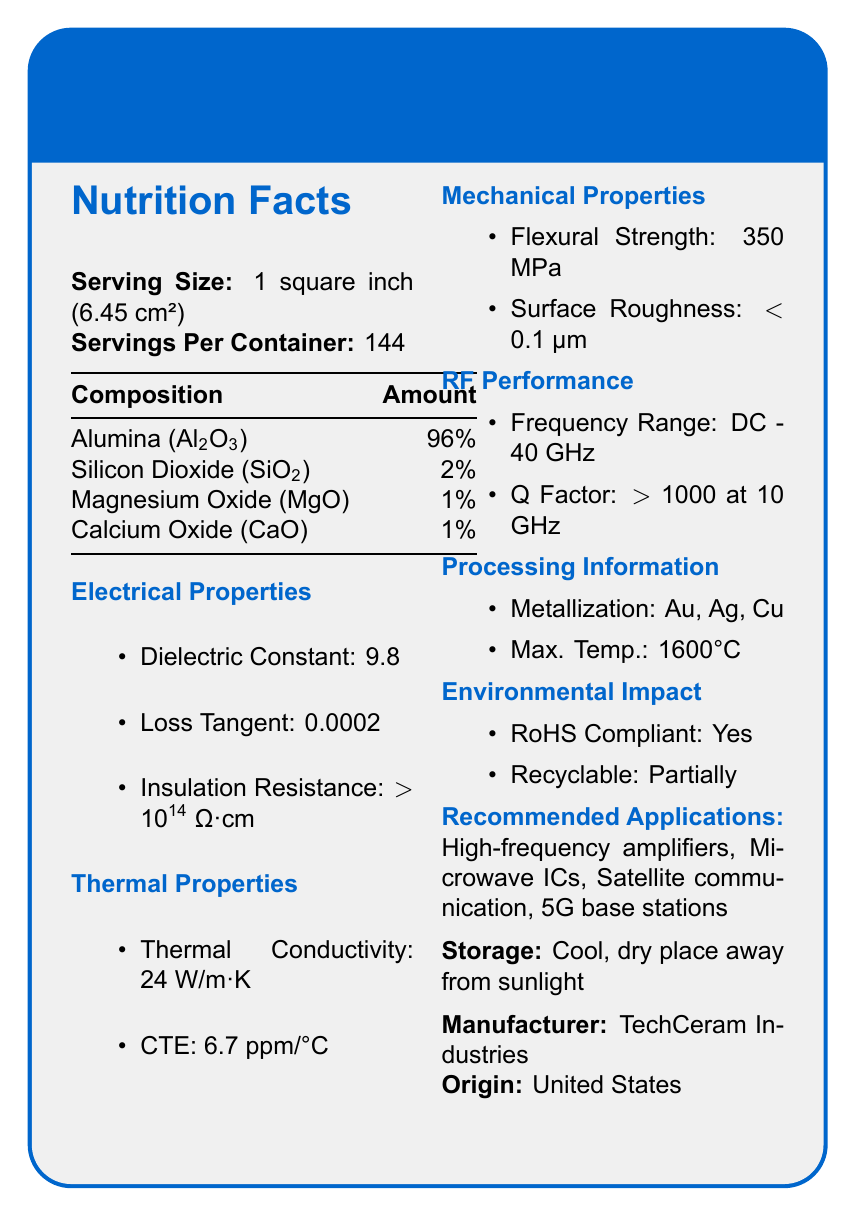what is the product name? The product name is clearly mentioned at the top of the document and in the title, "RF-Grade Ceramic Substrate".
Answer: RF-Grade Ceramic Substrate what is the insulation resistance of the ceramic substrate? Under the Electrical Properties section, the insulation resistance is listed as "> 10^14 Ω·cm".
Answer: > 10^14 Ω·cm What is the dielectric constant of this ceramic substrate? The dielectric constant is explicitly mentioned under the Electrical Properties section with a value of 9.8.
Answer: 9.8 which metals are compatible with metallization processes for this substrate? The Processing Information section lists "Gold, Silver, Copper" as compatible with metallization processes.
Answer: Gold, Silver, Copper What frequency range does the ceramic substrate support? The RF Performance section indicates that the ceramic substrate supports a frequency range from DC to 40 GHz.
Answer: DC - 40 GHz In which country is this substrate manufactured? The Country of Origin is mentioned as "United States" under the Manufacturer section.
Answer: United States which of the following is a component of the ceramic substrate? A. Zinc Oxide (ZnO) B. Silicon Dioxide (SiO2) C. Iron Oxide (Fe2O3) Under the Composition section, Silicon Dioxide (SiO2) is listed as a component, while the other options are not mentioned.
Answer: B. Silicon Dioxide (SiO2) What is the maximum processing temperature of the ceramic substrate? A. 1200°C B. 1400°C C. 1600°C D. 1800°C The Processing Information section specifies the maximum processing temperature as 1600°C.
Answer: C. 1600°C Is the ceramic substrate RoHS compliant? The Environmental Impact section confirms that the ceramic substrate is RoHS compliant.
Answer: Yes Summarize the main idea of the document. The document provides detailed specifications about the RF-Grade Ceramic Substrate, covering its composition, electrical, thermal, mechanical properties, processing information, environmental impact, and recommended applications, concluding with storage instructions and manufacturer details.
Answer: The RF-Grade Ceramic Substrate is a specialized material optimized for radio frequency circuit applications, featuring a high dielectric constant, low loss tangent, high insulation resistance, and robust thermal and mechanical properties. It is compatible with gold, silver, and copper metallization, can withstand high processing temperatures up to 1600°C, and is environmentally compliant. Its recommended applications include high-frequency amplifiers, microwave ICs, satellite communication, and 5G base stations. What is the recommended application for the ceramic substrate that involves mobile technology? Under the Recommended Applications section, "5G base stations" are listed, which are related to mobile technology.
Answer: 5G base stations What is the country of origin of the RF-Grade Ceramic Substrate? A. China B. Germany C. United States The document specifies that the country of origin is the United States under the Manufacturer section.
Answer: C. United States What is the coefficient of thermal expansion (CTE) of the ceramic substrate? Under the Thermal Properties section, the CTE is listed as 6.7 ppm/°C.
Answer: 6.7 ppm/°C What kind of roughness does the ceramic substrate surface exhibit? The Mechanical Properties section shows that the surface roughness of the ceramic substrate is less than 0.1 μm.
Answer: < 0.1 μm Can it be determined how much this ceramic substrate costs? The document does not provide any information regarding the cost of the ceramic substrate.
Answer: Cannot be determined Who is the manufacturer of the ceramic substrate? The manufacturer is listed as "TechCeram Industries" under the Manufacturer section.
Answer: TechCeram Industries What is one component NOT in the ceramic substrate? A. Alumina (Al2O3) B. Calcium Oxide (CaO) C. Titanium Dioxide (TiO2) D. Magnesium Oxide (MgO) The composition section lists Alumina, Calcium Oxide, and Magnesium Oxide, but Titanium Dioxide is not mentioned.
Answer: C. Titanium Dioxide (TiO2) 